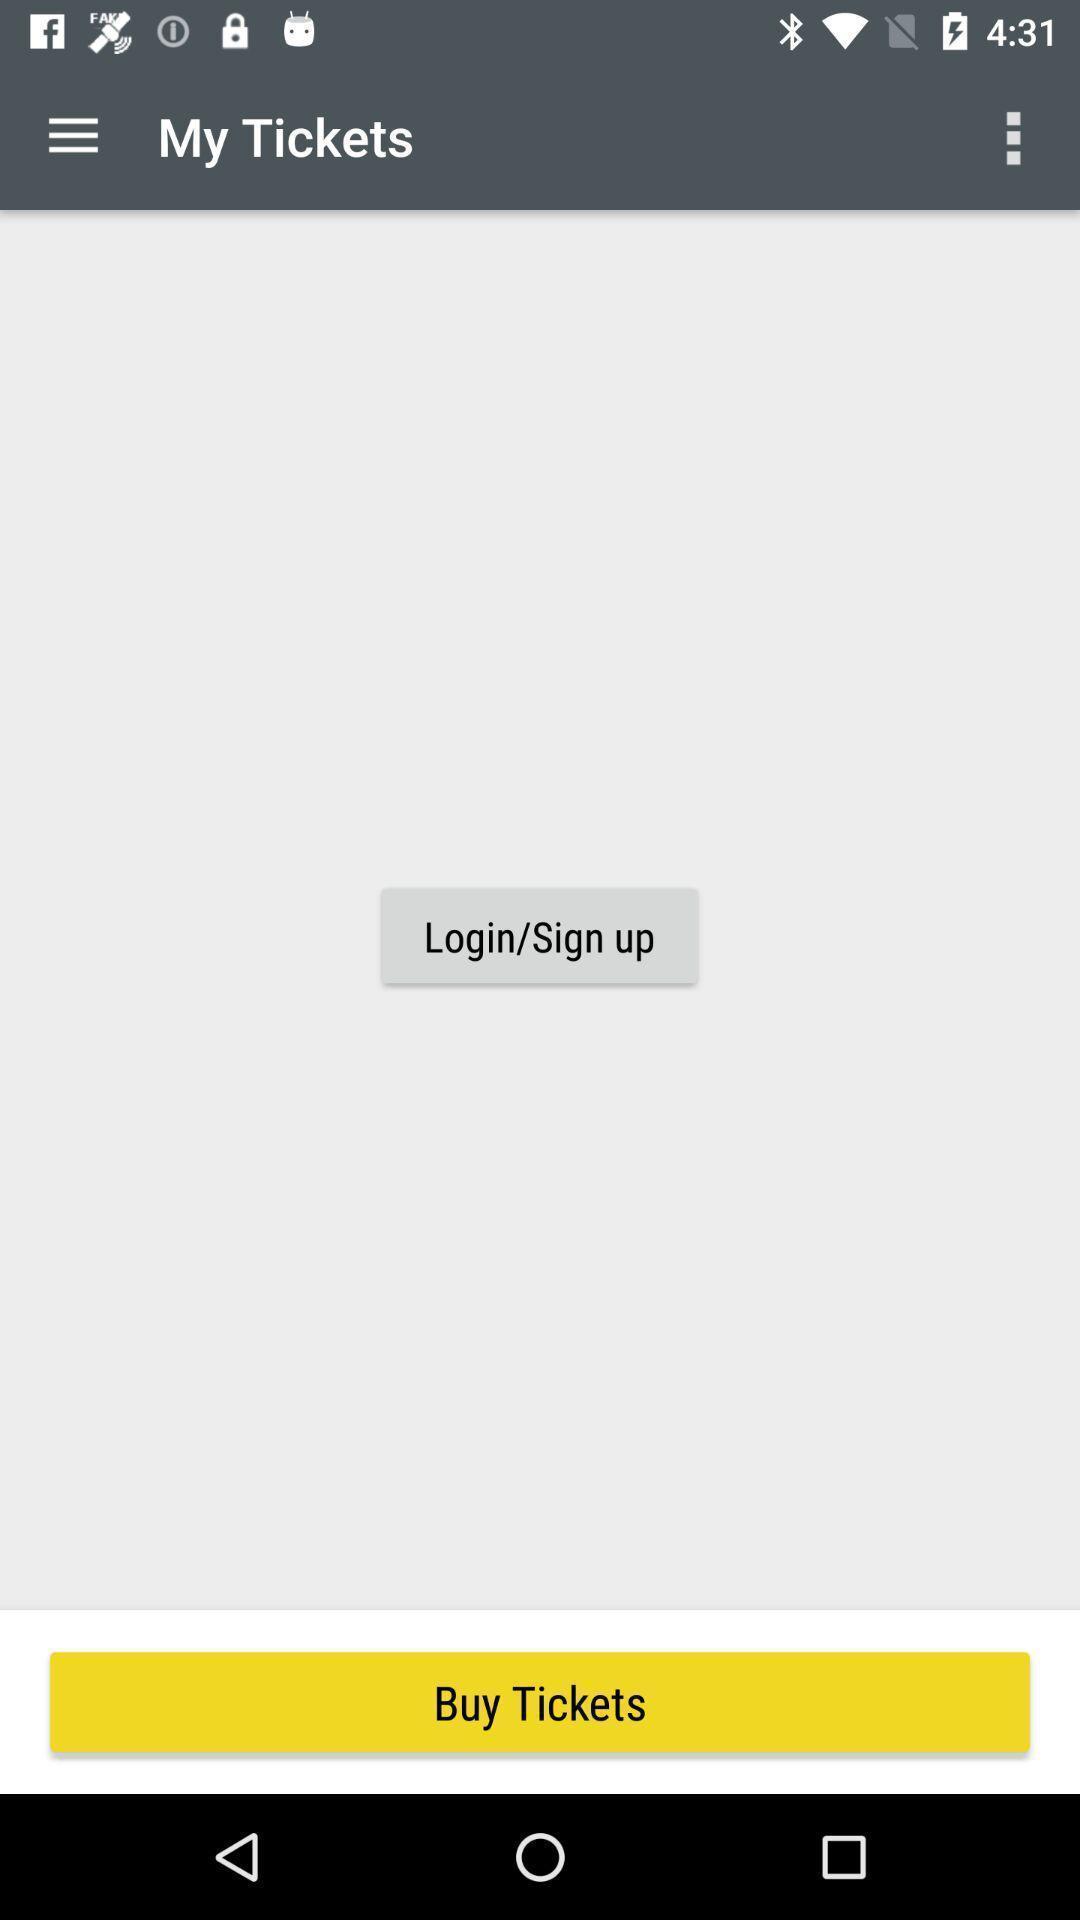Describe the key features of this screenshot. Sign in page. 